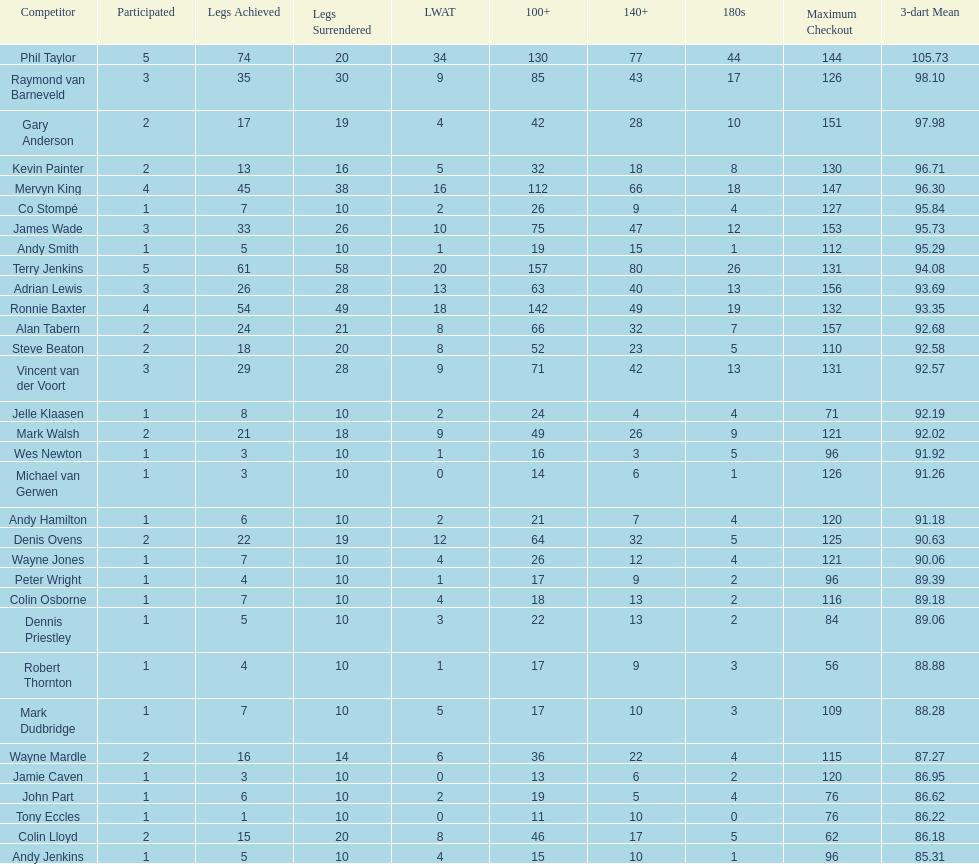Which player lost the least? Co Stompé, Andy Smith, Jelle Klaasen, Wes Newton, Michael van Gerwen, Andy Hamilton, Wayne Jones, Peter Wright, Colin Osborne, Dennis Priestley, Robert Thornton, Mark Dudbridge, Jamie Caven, John Part, Tony Eccles, Andy Jenkins. 